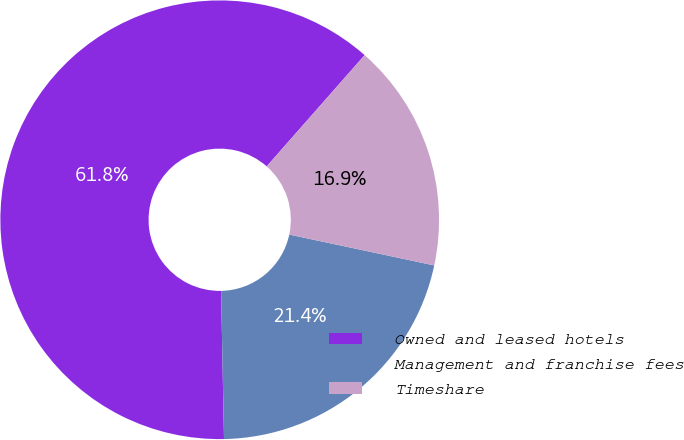<chart> <loc_0><loc_0><loc_500><loc_500><pie_chart><fcel>Owned and leased hotels<fcel>Management and franchise fees<fcel>Timeshare<nl><fcel>61.8%<fcel>21.35%<fcel>16.85%<nl></chart> 